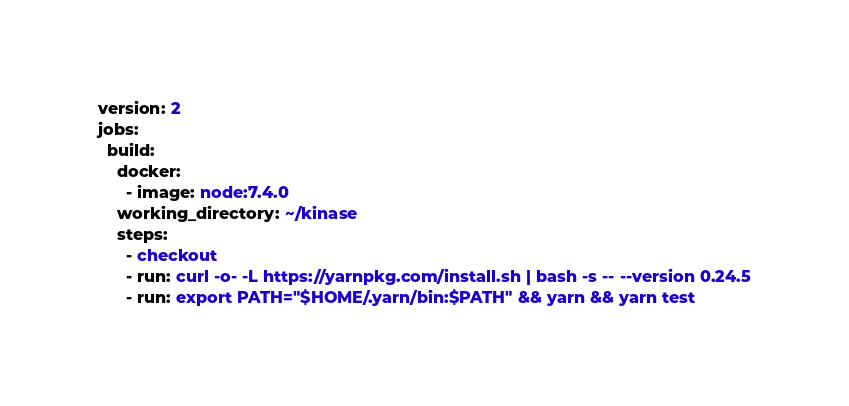<code> <loc_0><loc_0><loc_500><loc_500><_YAML_>version: 2
jobs:
  build:
    docker:
      - image: node:7.4.0
    working_directory: ~/kinase
    steps:
      - checkout
      - run: curl -o- -L https://yarnpkg.com/install.sh | bash -s -- --version 0.24.5
      - run: export PATH="$HOME/.yarn/bin:$PATH" && yarn && yarn test
</code> 